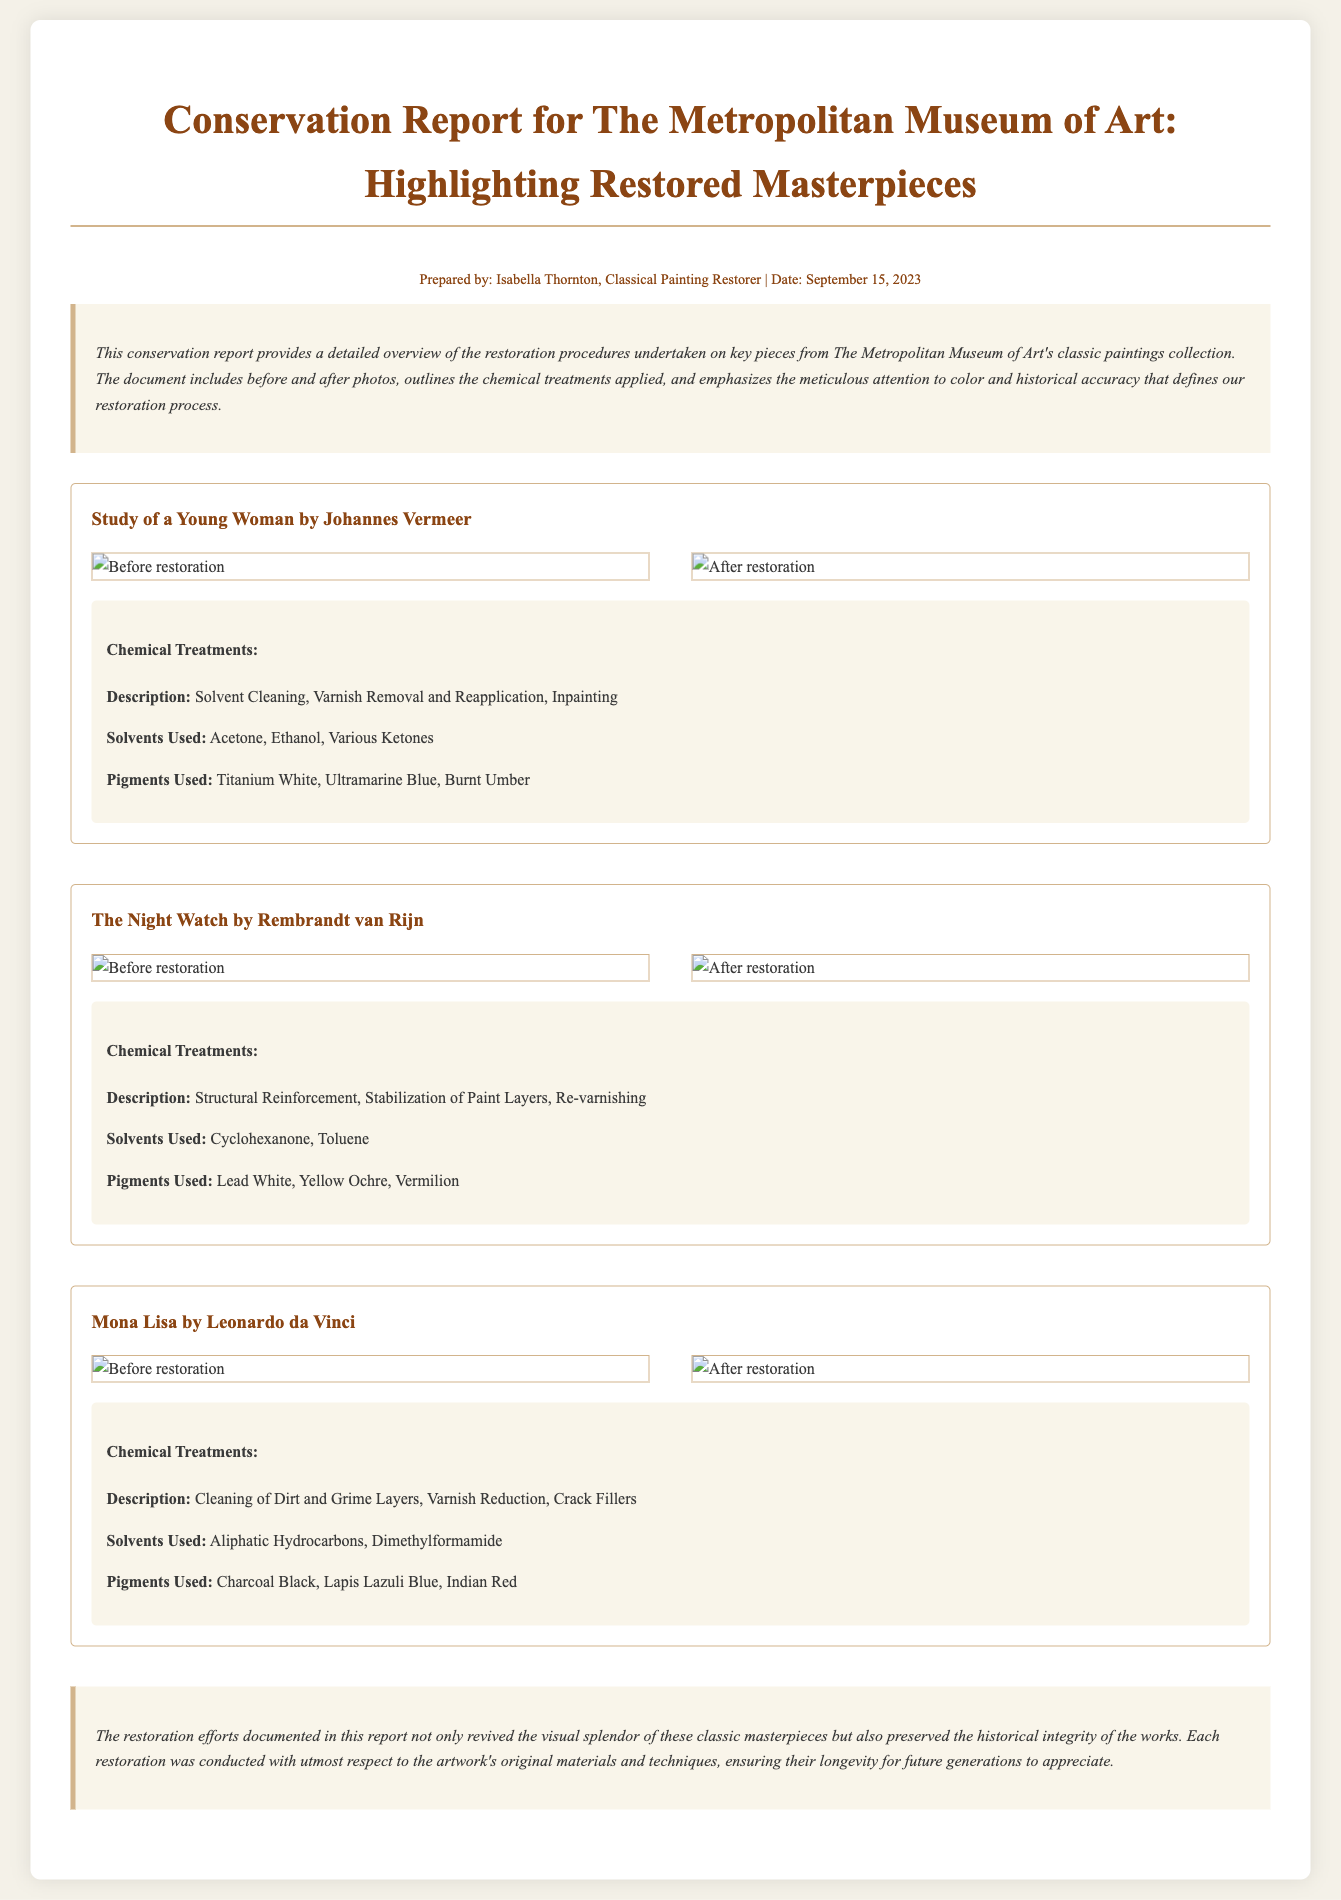What is the title of the report? The title of the report is indicated at the top of the document.
Answer: Conservation Report for The Metropolitan Museum of Art: Highlighting Restored Masterpieces Who prepared the report? The preparer's name is mentioned in the footer of the document.
Answer: Isabella Thornton What is the date of the report? The date is noted in the footer of the document.
Answer: September 15, 2023 Which painting underwent solvent cleaning and varnish removal? The restoration procedures are outlined under each painting section, including treatments applied.
Answer: Study of a Young Woman by Johannes Vermeer What pigments were used in the restoration of The Night Watch? The pigments used are specified in the treatments section of the respective painting.
Answer: Lead White, Yellow Ochre, Vermilion How many paintings are highlighted in this report? The number of paintings can be tallied from the sections labeled for each painting.
Answer: Three What type of chemical treatment was applied to the Mona Lisa? The chemical treatments for each painting are detailed within their respective sections.
Answer: Cleaning of Dirt and Grime Layers What were the solvents used on the Study of a Young Woman? Specific solvents are listed in the treatments section for that painting.
Answer: Acetone, Ethanol, Various Ketones What is the overall conclusion of the restoration efforts? The conclusion summarizes the impact of the restoration work, found in the conclusion section of the document.
Answer: Preserved the historical integrity of the works 